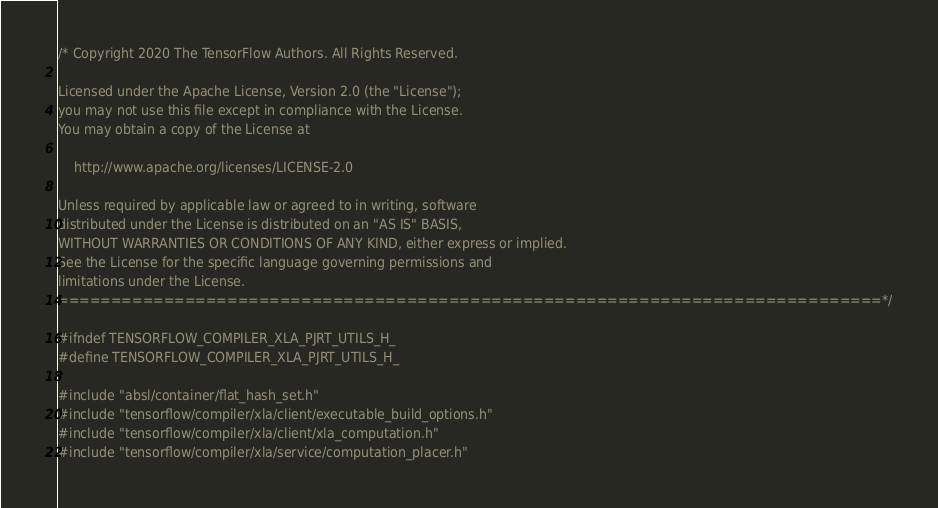Convert code to text. <code><loc_0><loc_0><loc_500><loc_500><_C_>/* Copyright 2020 The TensorFlow Authors. All Rights Reserved.

Licensed under the Apache License, Version 2.0 (the "License");
you may not use this file except in compliance with the License.
You may obtain a copy of the License at

    http://www.apache.org/licenses/LICENSE-2.0

Unless required by applicable law or agreed to in writing, software
distributed under the License is distributed on an "AS IS" BASIS,
WITHOUT WARRANTIES OR CONDITIONS OF ANY KIND, either express or implied.
See the License for the specific language governing permissions and
limitations under the License.
==============================================================================*/

#ifndef TENSORFLOW_COMPILER_XLA_PJRT_UTILS_H_
#define TENSORFLOW_COMPILER_XLA_PJRT_UTILS_H_

#include "absl/container/flat_hash_set.h"
#include "tensorflow/compiler/xla/client/executable_build_options.h"
#include "tensorflow/compiler/xla/client/xla_computation.h"
#include "tensorflow/compiler/xla/service/computation_placer.h"</code> 